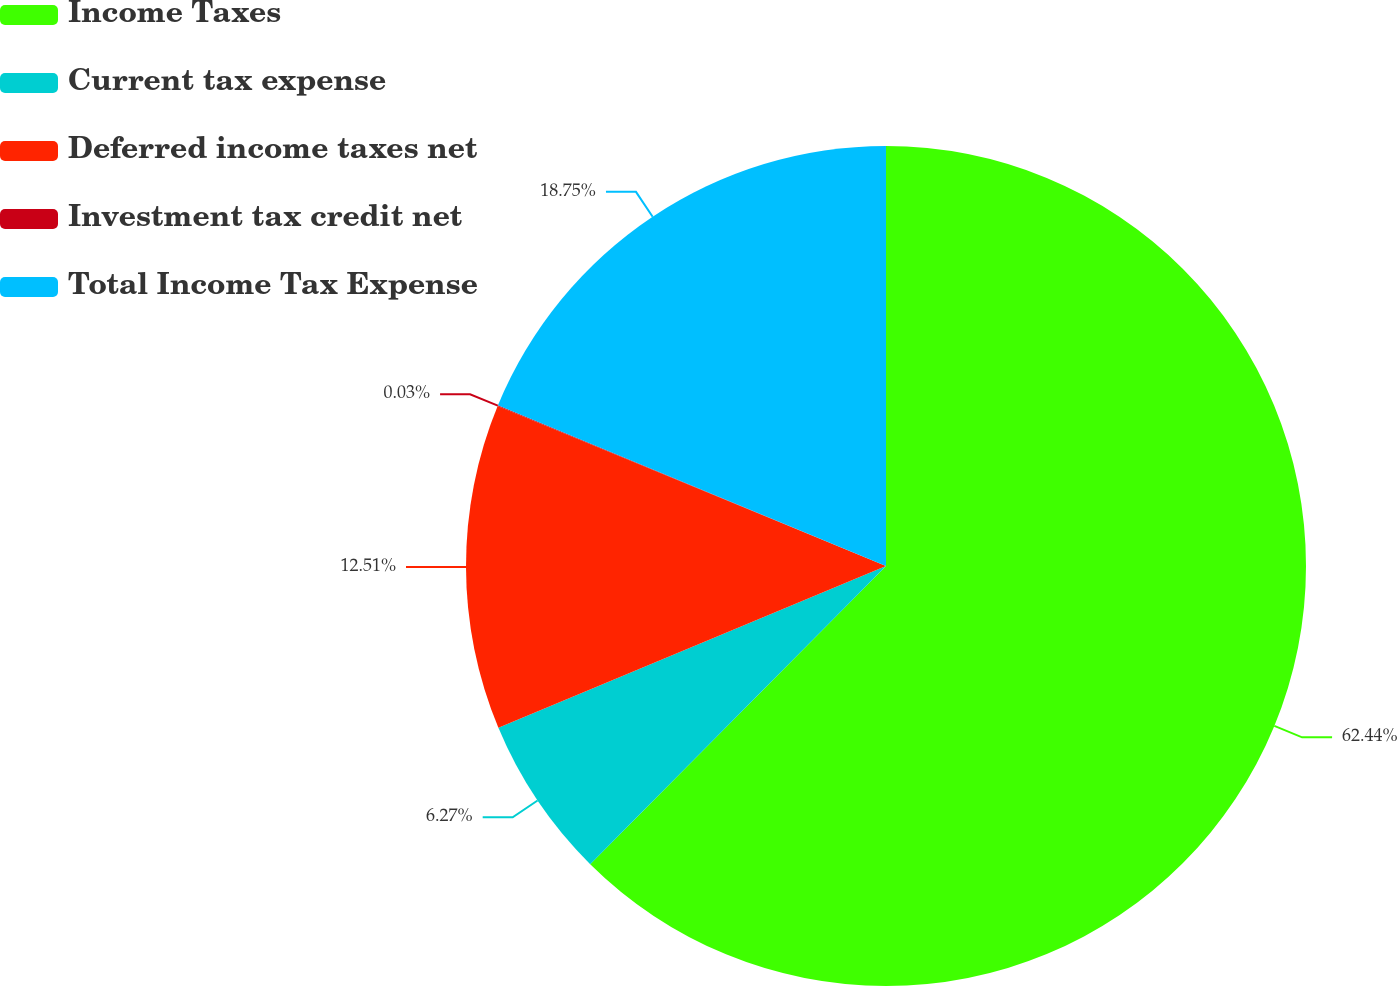Convert chart to OTSL. <chart><loc_0><loc_0><loc_500><loc_500><pie_chart><fcel>Income Taxes<fcel>Current tax expense<fcel>Deferred income taxes net<fcel>Investment tax credit net<fcel>Total Income Tax Expense<nl><fcel>62.43%<fcel>6.27%<fcel>12.51%<fcel>0.03%<fcel>18.75%<nl></chart> 